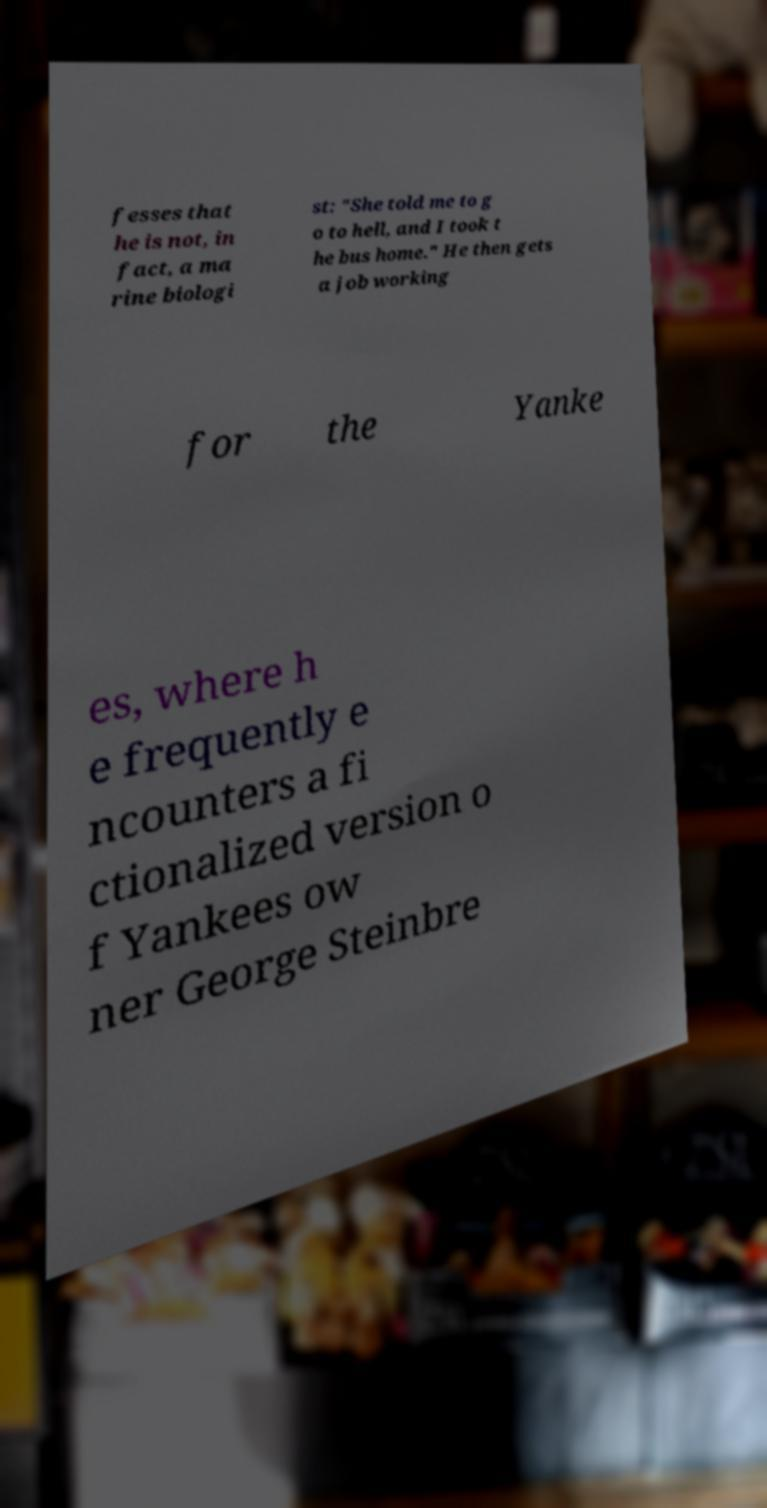Can you accurately transcribe the text from the provided image for me? fesses that he is not, in fact, a ma rine biologi st: "She told me to g o to hell, and I took t he bus home." He then gets a job working for the Yanke es, where h e frequently e ncounters a fi ctionalized version o f Yankees ow ner George Steinbre 